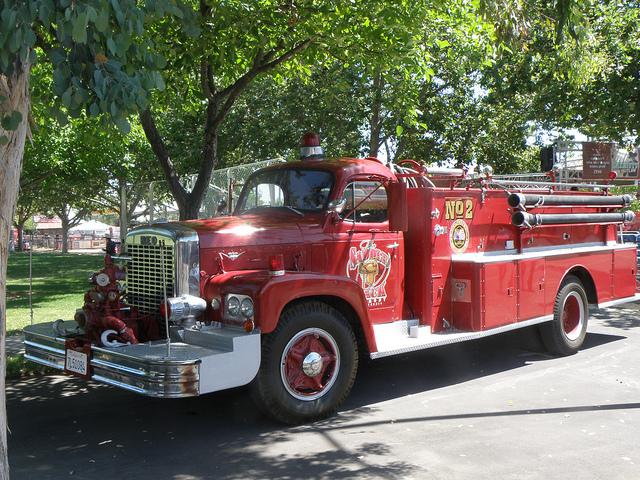Is this truck used in emergencies?
Write a very short answer. Yes. What color is this truck?
Be succinct. Red. Is this a fire truck?
Write a very short answer. Yes. 